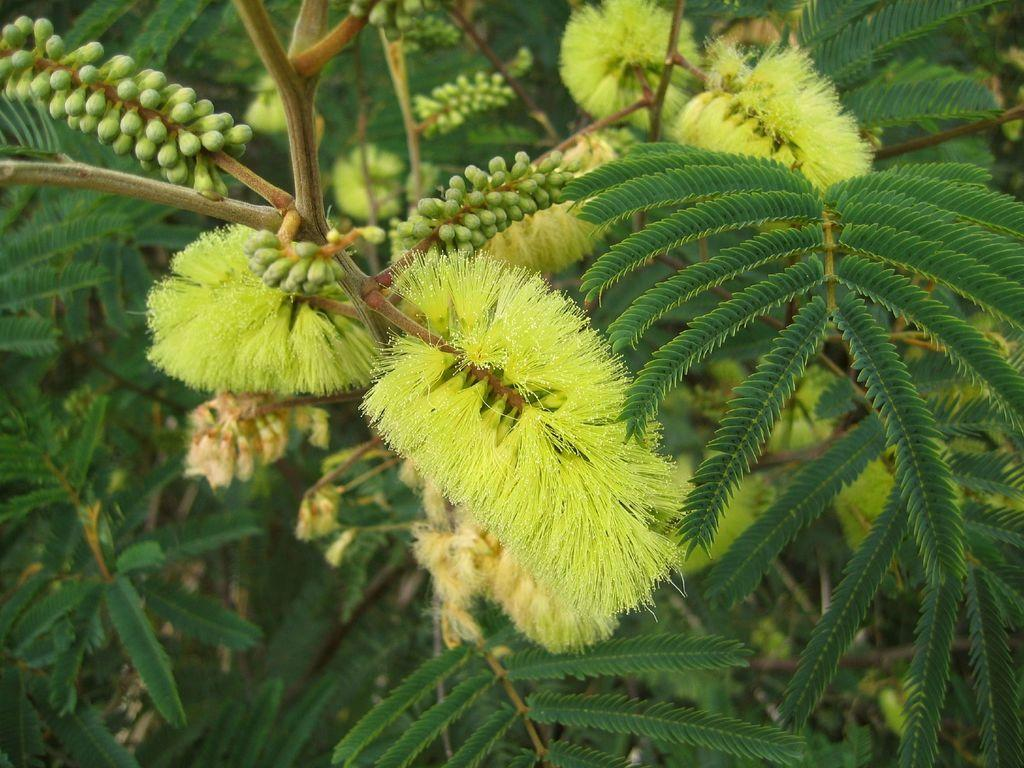What is present in the picture? There is a plant in the picture. What can be observed about the plant? The plant has flowers and buds of the flower. What is the color of the flowers? The flowers are in green color. What type of lunch is being prepared in the picture? There is no indication of lunch preparation in the image, as it features a plant with flowers and buds. 